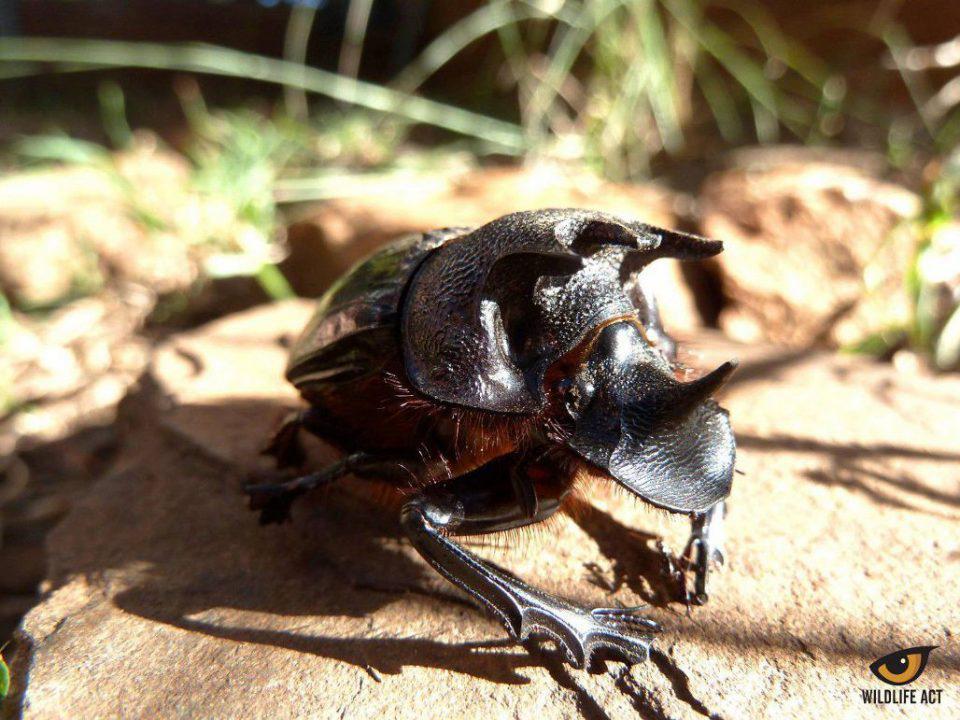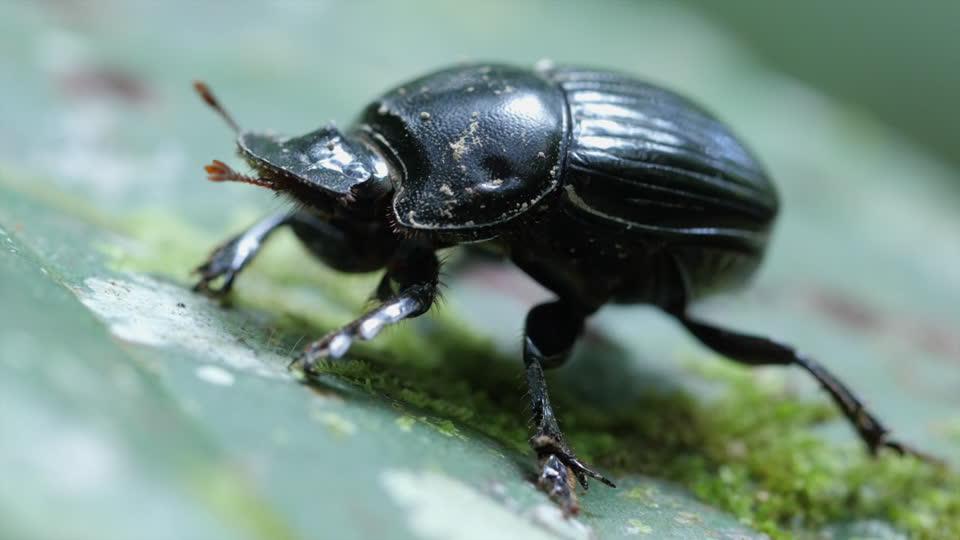The first image is the image on the left, the second image is the image on the right. Considering the images on both sides, is "An image shows a beetle with its hind legs on a dung ball and its head facing the ground." valid? Answer yes or no. No. The first image is the image on the left, the second image is the image on the right. Evaluate the accuracy of this statement regarding the images: "The beetle in the image on the left is on the right of the ball of dirt.". Is it true? Answer yes or no. No. 